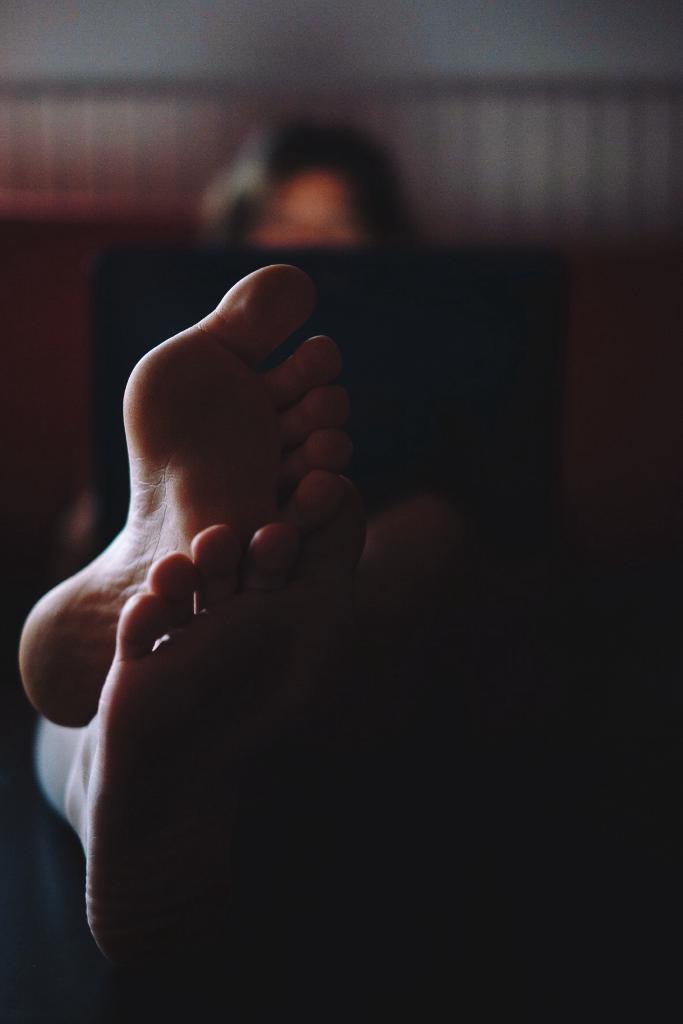Can you describe this image briefly? In this image I can see the person's legs. Background is blurred. 